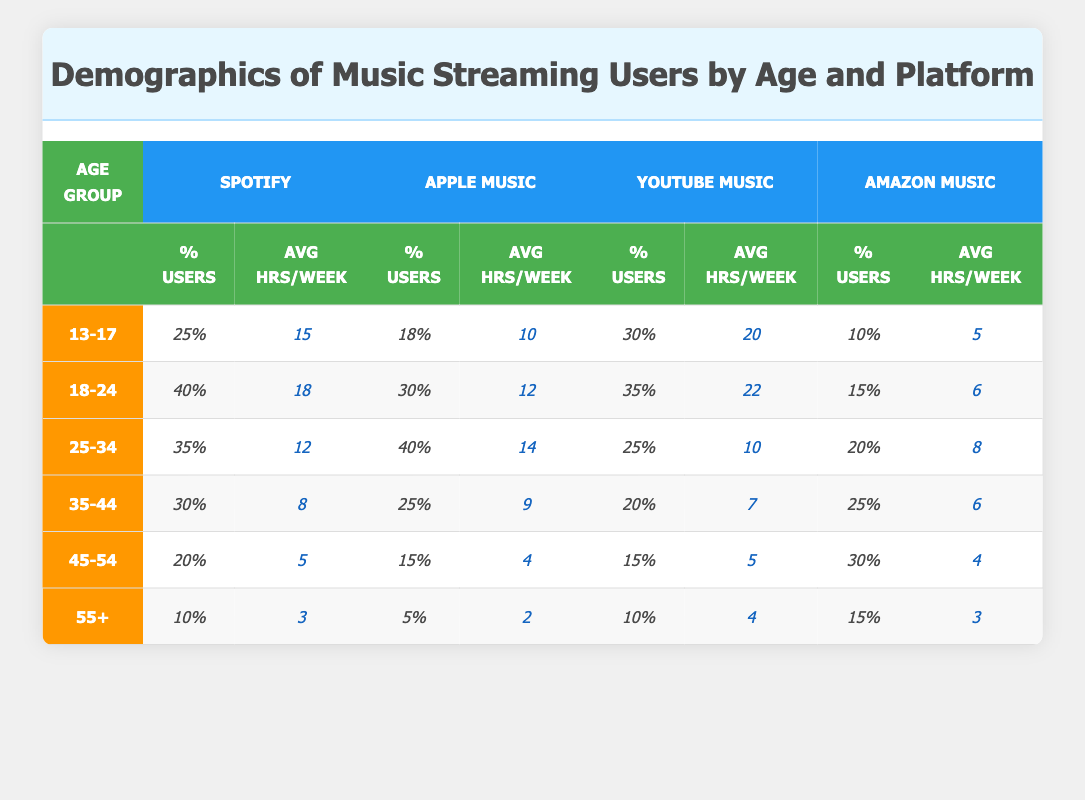What's the percentage of Spotify users in the 18-24 age group? According to the table, the percentage of Spotify users in the 18-24 age group is listed as 40%.
Answer: 40% Which music platform has the highest average hours per week for users aged 25-34? For users aged 25-34, YouTube Music shows the highest average hours per week at 10 hours.
Answer: 10 hours True or False: Amazon Music has a higher percentage of users in the 35-44 age group compared to Spotify. Looking at the table, Amazon Music has 25% of users in the 35-44 age group, while Spotify has 30%. Thus, the statement is false.
Answer: False What is the difference in average hours per week for Apple Music users between the 18-24 and 35-44 age groups? Apple Music users in the 18-24 age group listen for 12 hours, while users in the 35-44 age group listen for 9 hours. The difference is 12 - 9 = 3 hours.
Answer: 3 hours Which age group uses YouTube Music the most and what is the percentage? The age group 13-17 uses YouTube Music the most, with 30% of users in that category.
Answer: 30% What is the total percentage of Amazon Music users across all age groups? The total percentage of Amazon Music users can be calculated by adding all the percentages: 10% + 15% + 20% + 25% + 30% + 15% = 115%.
Answer: 115% How does the percentage of Spotify users in the 45-54 age group compare to that in the 55+ age group? The percentage of Spotify users in the 45-54 age group is 20% and in the 55+ age group is 10%, showing that there is a difference of 10%.
Answer: 10% Which platform has the lowest average hours per week for users aged 55+? In the 55+ age group, Apple Music has the lowest average hours per week at 2 hours.
Answer: 2 hours What is the average percentage of Apple Music users across all age groups? To find this, add all the percentages: 18% + 30% + 40% + 25% + 15% + 5% = 133%. Divide by the number of age groups (6): 133/6 = 22.17%.
Answer: 22.17% If users aged 35-44 listen to Spotify for 8 hours a week, how does this compare to user listening hours for YouTube Music in the same age group? For users aged 35-44, YouTube Music listening hours are 7. Thus, Spotify users listen for 1 hour more than YouTube Music users.
Answer: 1 hour more 